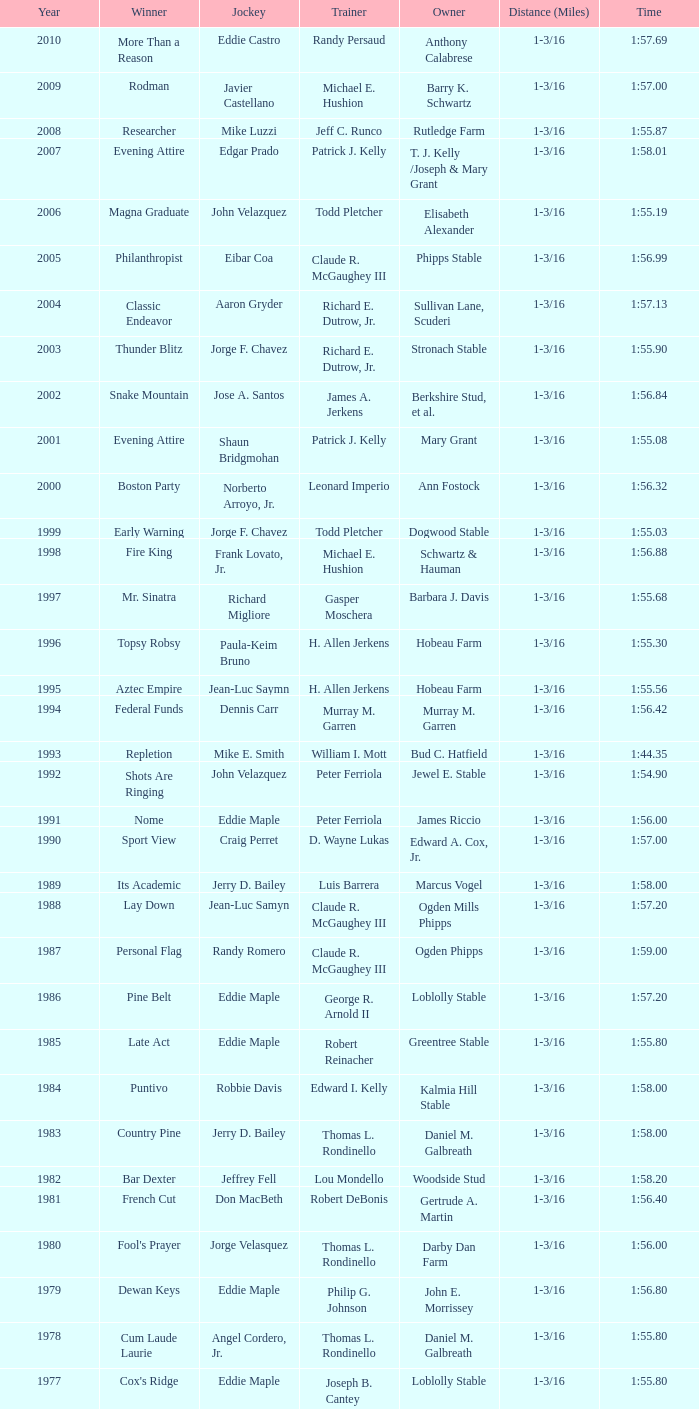What was the time for the winning horse Salford ii? 1:44.20. Help me parse the entirety of this table. {'header': ['Year', 'Winner', 'Jockey', 'Trainer', 'Owner', 'Distance (Miles)', 'Time'], 'rows': [['2010', 'More Than a Reason', 'Eddie Castro', 'Randy Persaud', 'Anthony Calabrese', '1-3/16', '1:57.69'], ['2009', 'Rodman', 'Javier Castellano', 'Michael E. Hushion', 'Barry K. Schwartz', '1-3/16', '1:57.00'], ['2008', 'Researcher', 'Mike Luzzi', 'Jeff C. Runco', 'Rutledge Farm', '1-3/16', '1:55.87'], ['2007', 'Evening Attire', 'Edgar Prado', 'Patrick J. Kelly', 'T. J. Kelly /Joseph & Mary Grant', '1-3/16', '1:58.01'], ['2006', 'Magna Graduate', 'John Velazquez', 'Todd Pletcher', 'Elisabeth Alexander', '1-3/16', '1:55.19'], ['2005', 'Philanthropist', 'Eibar Coa', 'Claude R. McGaughey III', 'Phipps Stable', '1-3/16', '1:56.99'], ['2004', 'Classic Endeavor', 'Aaron Gryder', 'Richard E. Dutrow, Jr.', 'Sullivan Lane, Scuderi', '1-3/16', '1:57.13'], ['2003', 'Thunder Blitz', 'Jorge F. Chavez', 'Richard E. Dutrow, Jr.', 'Stronach Stable', '1-3/16', '1:55.90'], ['2002', 'Snake Mountain', 'Jose A. Santos', 'James A. Jerkens', 'Berkshire Stud, et al.', '1-3/16', '1:56.84'], ['2001', 'Evening Attire', 'Shaun Bridgmohan', 'Patrick J. Kelly', 'Mary Grant', '1-3/16', '1:55.08'], ['2000', 'Boston Party', 'Norberto Arroyo, Jr.', 'Leonard Imperio', 'Ann Fostock', '1-3/16', '1:56.32'], ['1999', 'Early Warning', 'Jorge F. Chavez', 'Todd Pletcher', 'Dogwood Stable', '1-3/16', '1:55.03'], ['1998', 'Fire King', 'Frank Lovato, Jr.', 'Michael E. Hushion', 'Schwartz & Hauman', '1-3/16', '1:56.88'], ['1997', 'Mr. Sinatra', 'Richard Migliore', 'Gasper Moschera', 'Barbara J. Davis', '1-3/16', '1:55.68'], ['1996', 'Topsy Robsy', 'Paula-Keim Bruno', 'H. Allen Jerkens', 'Hobeau Farm', '1-3/16', '1:55.30'], ['1995', 'Aztec Empire', 'Jean-Luc Saymn', 'H. Allen Jerkens', 'Hobeau Farm', '1-3/16', '1:55.56'], ['1994', 'Federal Funds', 'Dennis Carr', 'Murray M. Garren', 'Murray M. Garren', '1-3/16', '1:56.42'], ['1993', 'Repletion', 'Mike E. Smith', 'William I. Mott', 'Bud C. Hatfield', '1-3/16', '1:44.35'], ['1992', 'Shots Are Ringing', 'John Velazquez', 'Peter Ferriola', 'Jewel E. Stable', '1-3/16', '1:54.90'], ['1991', 'Nome', 'Eddie Maple', 'Peter Ferriola', 'James Riccio', '1-3/16', '1:56.00'], ['1990', 'Sport View', 'Craig Perret', 'D. Wayne Lukas', 'Edward A. Cox, Jr.', '1-3/16', '1:57.00'], ['1989', 'Its Academic', 'Jerry D. Bailey', 'Luis Barrera', 'Marcus Vogel', '1-3/16', '1:58.00'], ['1988', 'Lay Down', 'Jean-Luc Samyn', 'Claude R. McGaughey III', 'Ogden Mills Phipps', '1-3/16', '1:57.20'], ['1987', 'Personal Flag', 'Randy Romero', 'Claude R. McGaughey III', 'Ogden Phipps', '1-3/16', '1:59.00'], ['1986', 'Pine Belt', 'Eddie Maple', 'George R. Arnold II', 'Loblolly Stable', '1-3/16', '1:57.20'], ['1985', 'Late Act', 'Eddie Maple', 'Robert Reinacher', 'Greentree Stable', '1-3/16', '1:55.80'], ['1984', 'Puntivo', 'Robbie Davis', 'Edward I. Kelly', 'Kalmia Hill Stable', '1-3/16', '1:58.00'], ['1983', 'Country Pine', 'Jerry D. Bailey', 'Thomas L. Rondinello', 'Daniel M. Galbreath', '1-3/16', '1:58.00'], ['1982', 'Bar Dexter', 'Jeffrey Fell', 'Lou Mondello', 'Woodside Stud', '1-3/16', '1:58.20'], ['1981', 'French Cut', 'Don MacBeth', 'Robert DeBonis', 'Gertrude A. Martin', '1-3/16', '1:56.40'], ['1980', "Fool's Prayer", 'Jorge Velasquez', 'Thomas L. Rondinello', 'Darby Dan Farm', '1-3/16', '1:56.00'], ['1979', 'Dewan Keys', 'Eddie Maple', 'Philip G. Johnson', 'John E. Morrissey', '1-3/16', '1:56.80'], ['1978', 'Cum Laude Laurie', 'Angel Cordero, Jr.', 'Thomas L. Rondinello', 'Daniel M. Galbreath', '1-3/16', '1:55.80'], ['1977', "Cox's Ridge", 'Eddie Maple', 'Joseph B. Cantey', 'Loblolly Stable', '1-3/16', '1:55.80'], ['1976', "It's Freezing", 'Jacinto Vasquez', 'Anthony Basile', 'Bwamazon Farm', '1-3/16', '1:56.60'], ['1975', 'Hail The Pirates', 'Ron Turcotte', 'Thomas L. Rondinello', 'Daniel M. Galbreath', '1-3/16', '1:55.60'], ['1974', 'Free Hand', 'Jose Amy', 'Pancho Martin', 'Sigmund Sommer', '1-3/16', '1:55.00'], ['1973', 'True Knight', 'Angel Cordero, Jr.', 'Thomas L. Rondinello', 'Darby Dan Farm', '1-3/16', '1:55.00'], ['1972', 'Sunny And Mild', 'Michael Venezia', 'W. Preston King', 'Harry Rogosin', '1-3/16', '1:54.40'], ['1971', 'Red Reality', 'Jorge Velasquez', 'MacKenzie Miller', 'Cragwood Stables', '1-1/8', '1:49.60'], ['1970', 'Best Turn', 'Larry Adams', 'Reggie Cornell', 'Calumet Farm', '1-1/8', '1:50.00'], ['1969', 'Vif', 'Larry Adams', 'Clarence Meaux', 'Harvey Peltier', '1-1/8', '1:49.20'], ['1968', 'Irish Dude', 'Sandino Hernandez', 'Jack Bradley', 'Richard W. Taylor', '1-1/8', '1:49.60'], ['1967', 'Mr. Right', 'Heliodoro Gustines', 'Evan S. Jackson', 'Mrs. Peter Duchin', '1-1/8', '1:49.60'], ['1966', 'Amberoid', 'Walter Blum', 'Lucien Laurin', 'Reginald N. Webster', '1-1/8', '1:50.60'], ['1965', 'Prairie Schooner', 'Eddie Belmonte', 'James W. Smith', 'High Tide Stable', '1-1/8', '1:50.20'], ['1964', 'Third Martini', 'William Boland', 'H. Allen Jerkens', 'Hobeau Farm', '1-1/8', '1:50.60'], ['1963', 'Uppercut', 'Manuel Ycaza', 'Willard C. Freeman', 'William Harmonay', '1-1/8', '1:35.40'], ['1962', 'Grid Iron Hero', 'Manuel Ycaza', 'Laz Barrera', 'Emil Dolce', '1 mile', '1:34.00'], ['1961', 'Manassa Mauler', 'Braulio Baeza', 'Pancho Martin', 'Emil Dolce', '1 mile', '1:36.20'], ['1960', 'Cranberry Sauce', 'Heliodoro Gustines', 'not found', 'Elmendorf Farm', '1 mile', '1:36.20'], ['1959', 'Whitley', 'Eric Guerin', 'Max Hirsch', 'W. Arnold Hanger', '1 mile', '1:36.40'], ['1958', 'Oh Johnny', 'William Boland', 'Norman R. McLeod', 'Mrs. Wallace Gilroy', '1-1/16', '1:43.40'], ['1957', 'Bold Ruler', 'Eddie Arcaro', 'James E. Fitzsimmons', 'Wheatley Stable', '1-1/16', '1:42.80'], ['1956', 'Blessbull', 'Willie Lester', 'not found', 'Morris Sims', '1-1/16', '1:42.00'], ['1955', 'Fabulist', 'Ted Atkinson', 'William C. Winfrey', 'High Tide Stable', '1-1/16', '1:43.60'], ['1954', 'Find', 'Eric Guerin', 'William C. Winfrey', 'Alfred G. Vanderbilt II', '1-1/16', '1:44.00'], ['1953', 'Flaunt', 'S. Cole', 'Hubert W. Williams', 'Arnold Skjeveland', '1-1/16', '1:44.20'], ['1952', 'County Delight', 'Dave Gorman', 'James E. Ryan', 'Rokeby Stable', '1-1/16', '1:43.60'], ['1951', 'Sheilas Reward', 'Ovie Scurlock', 'Eugene Jacobs', 'Mrs. Louis Lazare', '1-1/16', '1:44.60'], ['1950', 'Three Rings', 'Hedley Woodhouse', 'Willie Knapp', 'Mrs. Evelyn L. Hopkins', '1-1/16', '1:44.60'], ['1949', 'Three Rings', 'Ted Atkinson', 'Willie Knapp', 'Mrs. Evelyn L. Hopkins', '1-1/16', '1:47.40'], ['1948', 'Knockdown', 'Ferrill Zufelt', 'Tom Smith', 'Maine Chance Farm', '1-1/16', '1:44.60'], ['1947', 'Gallorette', 'Job Dean Jessop', 'Edward A. Christmas', 'William L. Brann', '1-1/16', '1:45.40'], ['1946', 'Helioptic', 'Paul Miller', 'not found', 'William Goadby Loew', '1-1/16', '1:43.20'], ['1945', 'Olympic Zenith', 'Conn McCreary', 'Willie Booth', 'William G. Helis', '1-1/16', '1:45.60'], ['1944', 'First Fiddle', 'Johnny Longden', 'Edward Mulrenan', 'Mrs. Edward Mulrenan', '1-1/16', '1:44.20'], ['1943', 'The Rhymer', 'Conn McCreary', 'John M. Gaver, Sr.', 'Greentree Stable', '1-1/16', '1:45.00'], ['1942', 'Waller', 'Billie Thompson', 'A. G. Robertson', 'John C. Clark', '1-1/16', '1:44.00'], ['1941', 'Salford II', 'Don Meade', 'not found', 'Ralph B. Strassburger', '1-1/16', '1:44.20'], ['1940', 'He Did', 'Eddie Arcaro', 'J. Thomas Taylor', 'W. Arnold Hanger', '1-1/16', '1:43.20'], ['1939', 'Lovely Night', 'Johnny Longden', 'Henry McDaniel', 'Mrs. F. Ambrose Clark', '1 mile', '1:36.40'], ['1938', 'War Admiral', 'Charles Kurtsinger', 'George Conway', 'Glen Riddle Farm', '1 mile', '1:36.80'], ['1937', 'Snark', 'Johnny Longden', 'James E. Fitzsimmons', 'Wheatley Stable', '1 mile', '1:37.40'], ['1936', 'Good Gamble', 'Samuel Renick', 'Bud Stotler', 'Alfred G. Vanderbilt II', '1 mile', '1:37.20'], ['1935', 'King Saxon', 'Calvin Rainey', 'Charles Shaw', 'C. H. Knebelkamp', '1 mile', '1:37.20'], ['1934', 'Singing Wood', 'Robert Jones', 'James W. Healy', 'Liz Whitney', '1 mile', '1:38.60'], ['1933', 'Kerry Patch', 'Robert Wholey', 'Joseph A. Notter', 'Lee Rosenberg', '1 mile', '1:38.00'], ['1932', 'Halcyon', 'Hank Mills', 'T. J. Healey', 'C. V. Whitney', '1 mile', '1:38.00'], ['1931', 'Halcyon', 'G. Rose', 'T. J. Healey', 'C. V. Whitney', '1 mile', '1:38.40'], ['1930', 'Kildare', 'John Passero', 'Norman Tallman', 'Newtondale Stable', '1 mile', '1:38.60'], ['1929', 'Comstockery', 'Sidney Hebert', 'Thomas W. Murphy', 'Greentree Stable', '1 mile', '1:39.60'], ['1928', 'Kentucky II', 'George Schreiner', 'Max Hirsch', 'A. Charles Schwartz', '1 mile', '1:38.80'], ['1927', 'Light Carbine', 'James McCoy', 'M. J. Dunlevy', 'I. B. Humphreys', '1 mile', '1:36.80'], ['1926', 'Macaw', 'Linus McAtee', 'James G. Rowe, Sr.', 'Harry Payne Whitney', '1 mile', '1:37.00'], ['1925', 'Mad Play', 'Laverne Fator', 'Sam Hildreth', 'Rancocas Stable', '1 mile', '1:36.60'], ['1924', 'Mad Hatter', 'Earl Sande', 'Sam Hildreth', 'Rancocas Stable', '1 mile', '1:36.60'], ['1923', 'Zev', 'Earl Sande', 'Sam Hildreth', 'Rancocas Stable', '1 mile', '1:37.00'], ['1922', 'Grey Lag', 'Laverne Fator', 'Sam Hildreth', 'Rancocas Stable', '1 mile', '1:38.00'], ['1921', 'John P. Grier', 'Frank Keogh', 'James G. Rowe, Sr.', 'Harry Payne Whitney', '1 mile', '1:36.00'], ['1920', 'Cirrus', 'Lavelle Ensor', 'Sam Hildreth', 'Sam Hildreth', '1 mile', '1:38.00'], ['1919', 'Star Master', 'Merritt Buxton', 'Walter B. Jennings', 'A. Kingsley Macomber', '1 mile', '1:37.60'], ['1918', 'Roamer', 'Lawrence Lyke', 'A. J. Goldsborough', 'Andrew Miller', '1 mile', '1:36.60'], ['1917', 'Old Rosebud', 'Frank Robinson', 'Frank D. Weir', 'F. D. Weir & Hamilton C. Applegate', '1 mile', '1:37.60'], ['1916', 'Short Grass', 'Frank Keogh', 'not found', 'Emil Herz', '1 mile', '1:36.40'], ['1915', 'Roamer', 'James Butwell', 'A. J. Goldsborough', 'Andrew Miller', '1 mile', '1:39.20'], ['1914', 'Flying Fairy', 'Tommy Davies', 'J. Simon Healy', 'Edward B. Cassatt', '1 mile', '1:42.20'], ['1913', 'No Race', 'No Race', 'No Race', 'No Race', '1 mile', 'no race'], ['1912', 'No Race', 'No Race', 'No Race', 'No Race', '1 mile', 'no race'], ['1911', 'No Race', 'No Race', 'No Race', 'No Race', '1 mile', 'no race'], ['1910', 'Arasee', 'Buddy Glass', 'Andrew G. Blakely', 'Samuel Emery', '1 mile', '1:39.80'], ['1909', 'No Race', 'No Race', 'No Race', 'No Race', '1 mile', 'no race'], ['1908', 'Jack Atkin', 'Phil Musgrave', 'Herman R. Brandt', 'Barney Schreiber', '1 mile', '1:39.00'], ['1907', 'W. H. Carey', 'George Mountain', 'James Blute', 'Richard F. Carman', '1 mile', '1:40.00'], ['1906', "Ram's Horn", 'L. Perrine', 'W. S. "Jim" Williams', 'W. S. "Jim" Williams', '1 mile', '1:39.40'], ['1905', 'St. Valentine', 'William Crimmins', 'John Shields', 'Alexander Shields', '1 mile', '1:39.20'], ['1904', 'Rosetint', 'Thomas H. Burns', 'James Boden', 'John Boden', '1 mile', '1:39.20'], ['1903', 'Yellow Tail', 'Willie Shaw', 'H. E. Rowell', 'John Hackett', '1m 70yds', '1:45.20'], ['1902', 'Margravite', 'Otto Wonderly', 'not found', 'Charles Fleischmann Sons', '1m 70 yds', '1:46.00']]} 